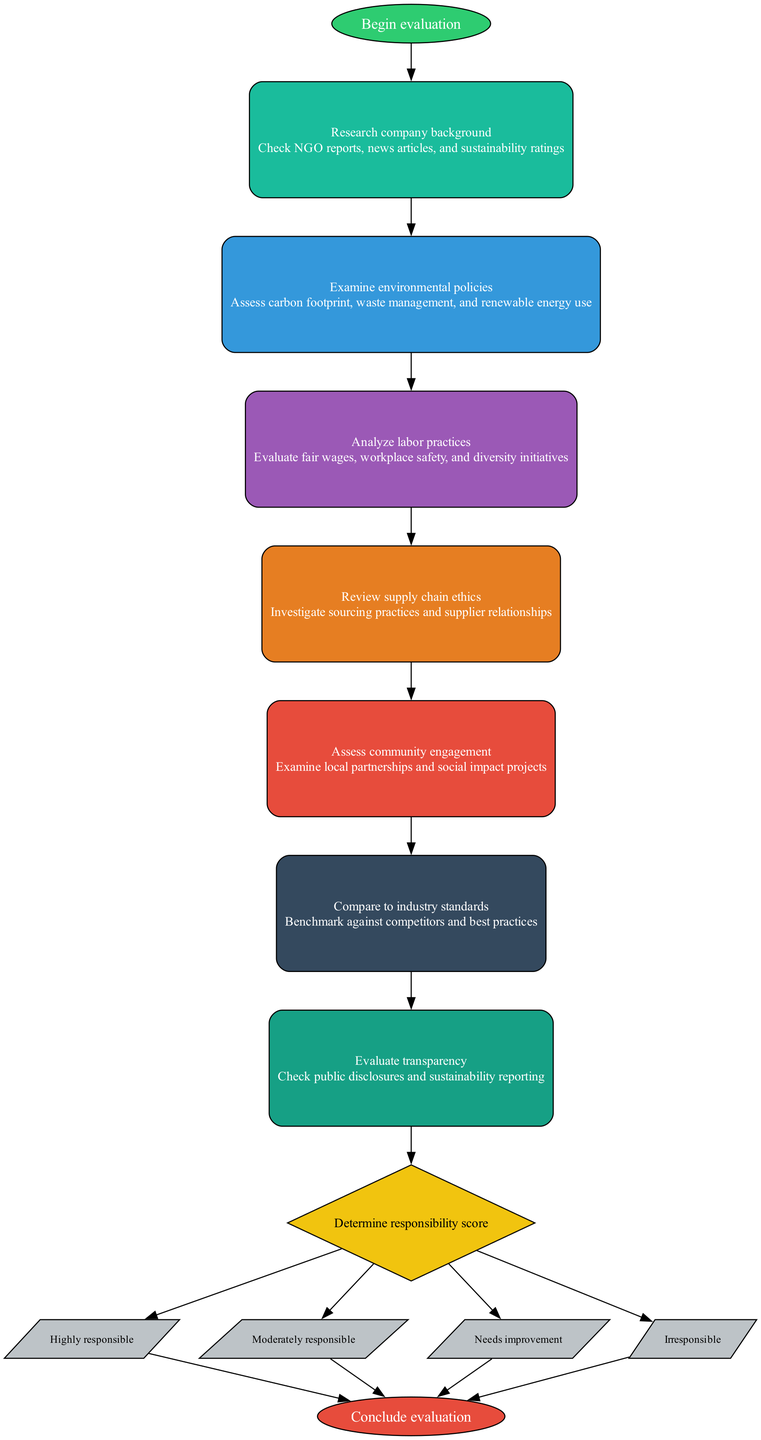What is the first step in the evaluation process? The first step in the evaluation process is "Research company background." This can be identified as it is the first node after the start node in the flow chart.
Answer: Research company background How many steps are there in the evaluation process? By counting the nodes that represent each step, we can see that there are a total of seven steps before reaching the decision node.
Answer: Seven What node comes after "Examine environmental policies"? The node that comes after "Examine environmental policies" is "Analyze labor practices." This follows the order in which the steps are connected in the diagram.
Answer: Analyze labor practices What are the options available at the decision node? The options available at the decision node are "Highly responsible," "Moderately responsible," "Needs improvement," and "Irresponsible." These options branch out from the decision node.
Answer: Highly responsible, Moderately responsible, Needs improvement, Irresponsible What is the purpose of the "Determine responsibility score" node? The purpose of the "Determine responsibility score" node is to evaluate the compiled information from previous steps and categorize the company's responsibility based on specific criteria. It acts as the decision-making point before concluding the evaluation.
Answer: Evaluate responsibility How do you move from one step to another in the flowchart? You can move from one step to another in the flowchart by following directed edges that connect the nodes in sequential order, representing the progression through the evaluation process.
Answer: Follow directed edges Which step assesses community engagement? The step that assesses community engagement is "Assess community engagement." This is clearly indicated within the steps listed in the flowchart.
Answer: Assess community engagement What color represents the decision node? The color representing the decision node is yellow, specifically represented by the fill color '#F1C40F' in the diagram's design.
Answer: Yellow 